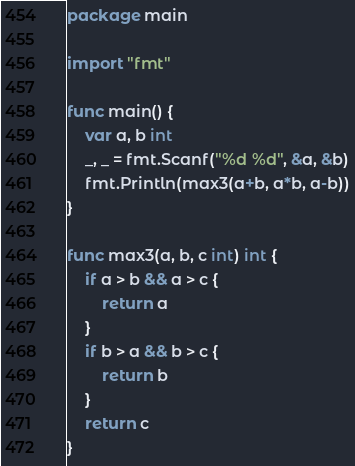Convert code to text. <code><loc_0><loc_0><loc_500><loc_500><_Go_>package main

import "fmt"

func main() {
	var a, b int
	_, _ = fmt.Scanf("%d %d", &a, &b)
	fmt.Println(max3(a+b, a*b, a-b))
}

func max3(a, b, c int) int {
	if a > b && a > c {
		return a
	}
	if b > a && b > c {
		return b
	}
	return c
}
</code> 